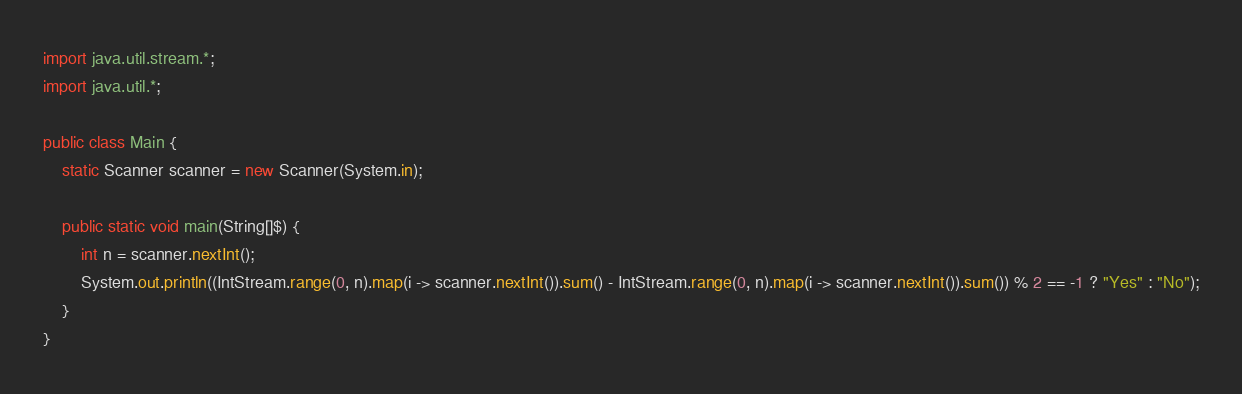Convert code to text. <code><loc_0><loc_0><loc_500><loc_500><_Java_>import java.util.stream.*;
import java.util.*;

public class Main {
    static Scanner scanner = new Scanner(System.in);

    public static void main(String[]$) {
        int n = scanner.nextInt();
        System.out.println((IntStream.range(0, n).map(i -> scanner.nextInt()).sum() - IntStream.range(0, n).map(i -> scanner.nextInt()).sum()) % 2 == -1 ? "Yes" : "No");
    }
}</code> 